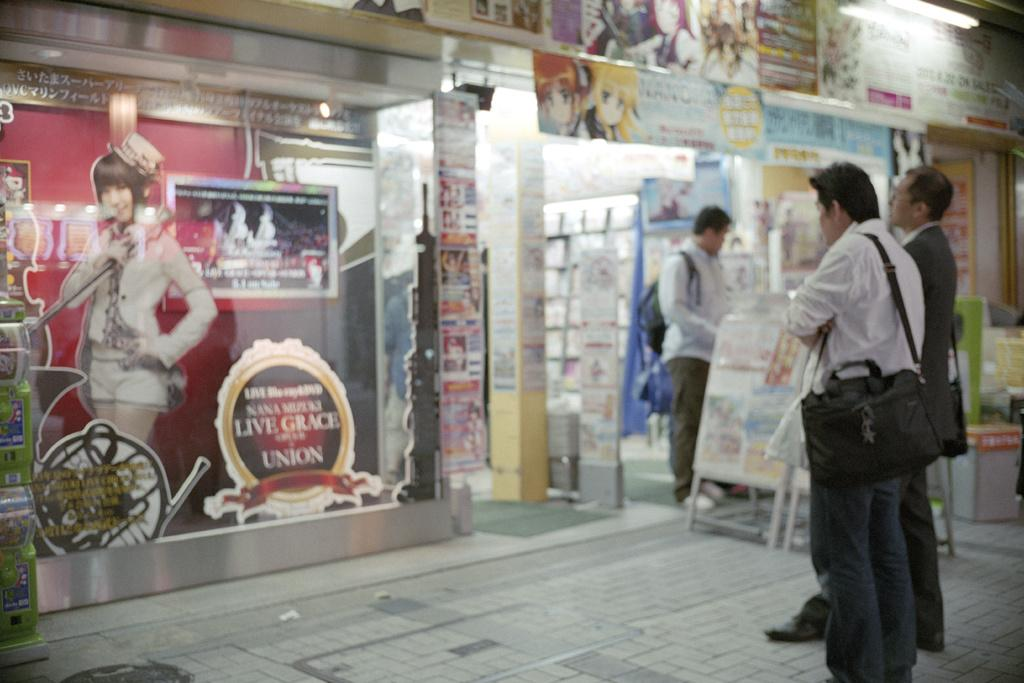<image>
Create a compact narrative representing the image presented. The window has a stick with the words Live Grace on it 